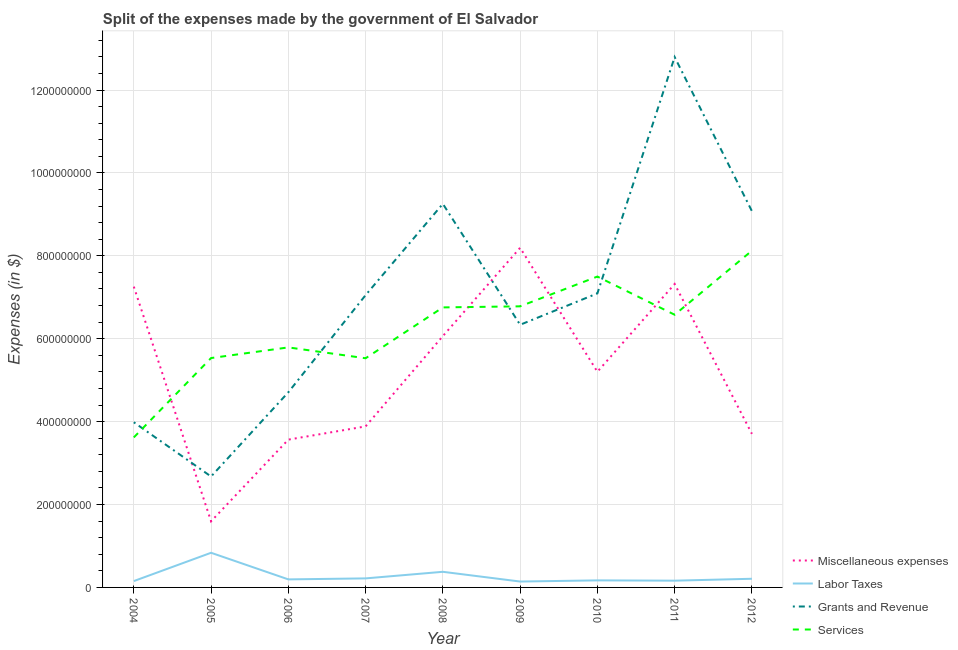Does the line corresponding to amount spent on labor taxes intersect with the line corresponding to amount spent on grants and revenue?
Provide a succinct answer. No. Is the number of lines equal to the number of legend labels?
Your answer should be compact. Yes. What is the amount spent on miscellaneous expenses in 2010?
Offer a very short reply. 5.20e+08. Across all years, what is the maximum amount spent on grants and revenue?
Provide a succinct answer. 1.28e+09. Across all years, what is the minimum amount spent on services?
Keep it short and to the point. 3.62e+08. In which year was the amount spent on grants and revenue minimum?
Offer a very short reply. 2005. What is the total amount spent on labor taxes in the graph?
Ensure brevity in your answer.  2.46e+08. What is the difference between the amount spent on labor taxes in 2011 and that in 2012?
Offer a very short reply. -4.60e+06. What is the difference between the amount spent on grants and revenue in 2004 and the amount spent on labor taxes in 2007?
Offer a very short reply. 3.77e+08. What is the average amount spent on grants and revenue per year?
Your response must be concise. 7.00e+08. In the year 2008, what is the difference between the amount spent on services and amount spent on labor taxes?
Your answer should be compact. 6.38e+08. In how many years, is the amount spent on grants and revenue greater than 80000000 $?
Offer a very short reply. 9. What is the ratio of the amount spent on grants and revenue in 2004 to that in 2008?
Provide a short and direct response. 0.43. Is the amount spent on grants and revenue in 2010 less than that in 2012?
Ensure brevity in your answer.  Yes. Is the difference between the amount spent on services in 2007 and 2008 greater than the difference between the amount spent on miscellaneous expenses in 2007 and 2008?
Your answer should be compact. Yes. What is the difference between the highest and the second highest amount spent on labor taxes?
Your answer should be very brief. 4.59e+07. What is the difference between the highest and the lowest amount spent on services?
Your answer should be very brief. 4.51e+08. Is the sum of the amount spent on labor taxes in 2009 and 2012 greater than the maximum amount spent on services across all years?
Your answer should be very brief. No. Is it the case that in every year, the sum of the amount spent on services and amount spent on labor taxes is greater than the sum of amount spent on miscellaneous expenses and amount spent on grants and revenue?
Make the answer very short. No. Is it the case that in every year, the sum of the amount spent on miscellaneous expenses and amount spent on labor taxes is greater than the amount spent on grants and revenue?
Your answer should be compact. No. Is the amount spent on services strictly less than the amount spent on miscellaneous expenses over the years?
Offer a terse response. No. Does the graph contain any zero values?
Your answer should be very brief. No. Does the graph contain grids?
Your answer should be compact. Yes. What is the title of the graph?
Your response must be concise. Split of the expenses made by the government of El Salvador. Does "Interest Payments" appear as one of the legend labels in the graph?
Provide a short and direct response. No. What is the label or title of the X-axis?
Keep it short and to the point. Year. What is the label or title of the Y-axis?
Give a very brief answer. Expenses (in $). What is the Expenses (in $) of Miscellaneous expenses in 2004?
Ensure brevity in your answer.  7.26e+08. What is the Expenses (in $) in Labor Taxes in 2004?
Your response must be concise. 1.53e+07. What is the Expenses (in $) in Grants and Revenue in 2004?
Offer a very short reply. 3.98e+08. What is the Expenses (in $) of Services in 2004?
Provide a succinct answer. 3.62e+08. What is the Expenses (in $) of Miscellaneous expenses in 2005?
Your response must be concise. 1.60e+08. What is the Expenses (in $) in Labor Taxes in 2005?
Offer a very short reply. 8.36e+07. What is the Expenses (in $) in Grants and Revenue in 2005?
Make the answer very short. 2.68e+08. What is the Expenses (in $) in Services in 2005?
Give a very brief answer. 5.53e+08. What is the Expenses (in $) of Miscellaneous expenses in 2006?
Offer a terse response. 3.57e+08. What is the Expenses (in $) in Labor Taxes in 2006?
Make the answer very short. 1.94e+07. What is the Expenses (in $) of Grants and Revenue in 2006?
Make the answer very short. 4.71e+08. What is the Expenses (in $) of Services in 2006?
Offer a terse response. 5.79e+08. What is the Expenses (in $) of Miscellaneous expenses in 2007?
Provide a succinct answer. 3.88e+08. What is the Expenses (in $) in Labor Taxes in 2007?
Your answer should be compact. 2.18e+07. What is the Expenses (in $) in Grants and Revenue in 2007?
Offer a very short reply. 7.05e+08. What is the Expenses (in $) in Services in 2007?
Your response must be concise. 5.53e+08. What is the Expenses (in $) of Miscellaneous expenses in 2008?
Keep it short and to the point. 6.06e+08. What is the Expenses (in $) of Labor Taxes in 2008?
Provide a short and direct response. 3.77e+07. What is the Expenses (in $) in Grants and Revenue in 2008?
Offer a very short reply. 9.26e+08. What is the Expenses (in $) of Services in 2008?
Provide a short and direct response. 6.76e+08. What is the Expenses (in $) in Miscellaneous expenses in 2009?
Your answer should be compact. 8.19e+08. What is the Expenses (in $) of Labor Taxes in 2009?
Your response must be concise. 1.42e+07. What is the Expenses (in $) in Grants and Revenue in 2009?
Provide a short and direct response. 6.34e+08. What is the Expenses (in $) of Services in 2009?
Your response must be concise. 6.78e+08. What is the Expenses (in $) of Miscellaneous expenses in 2010?
Offer a terse response. 5.20e+08. What is the Expenses (in $) of Labor Taxes in 2010?
Ensure brevity in your answer.  1.70e+07. What is the Expenses (in $) in Grants and Revenue in 2010?
Provide a short and direct response. 7.09e+08. What is the Expenses (in $) in Services in 2010?
Your answer should be very brief. 7.50e+08. What is the Expenses (in $) in Miscellaneous expenses in 2011?
Provide a succinct answer. 7.32e+08. What is the Expenses (in $) in Labor Taxes in 2011?
Your response must be concise. 1.63e+07. What is the Expenses (in $) of Grants and Revenue in 2011?
Keep it short and to the point. 1.28e+09. What is the Expenses (in $) in Services in 2011?
Your answer should be very brief. 6.58e+08. What is the Expenses (in $) of Miscellaneous expenses in 2012?
Your answer should be compact. 3.70e+08. What is the Expenses (in $) in Labor Taxes in 2012?
Offer a very short reply. 2.09e+07. What is the Expenses (in $) of Grants and Revenue in 2012?
Your answer should be very brief. 9.08e+08. What is the Expenses (in $) of Services in 2012?
Offer a terse response. 8.12e+08. Across all years, what is the maximum Expenses (in $) in Miscellaneous expenses?
Provide a short and direct response. 8.19e+08. Across all years, what is the maximum Expenses (in $) in Labor Taxes?
Provide a succinct answer. 8.36e+07. Across all years, what is the maximum Expenses (in $) in Grants and Revenue?
Keep it short and to the point. 1.28e+09. Across all years, what is the maximum Expenses (in $) in Services?
Your response must be concise. 8.12e+08. Across all years, what is the minimum Expenses (in $) in Miscellaneous expenses?
Provide a succinct answer. 1.60e+08. Across all years, what is the minimum Expenses (in $) of Labor Taxes?
Offer a very short reply. 1.42e+07. Across all years, what is the minimum Expenses (in $) in Grants and Revenue?
Give a very brief answer. 2.68e+08. Across all years, what is the minimum Expenses (in $) in Services?
Offer a very short reply. 3.62e+08. What is the total Expenses (in $) in Miscellaneous expenses in the graph?
Provide a succinct answer. 4.68e+09. What is the total Expenses (in $) in Labor Taxes in the graph?
Provide a short and direct response. 2.46e+08. What is the total Expenses (in $) in Grants and Revenue in the graph?
Provide a short and direct response. 6.30e+09. What is the total Expenses (in $) in Services in the graph?
Provide a short and direct response. 5.62e+09. What is the difference between the Expenses (in $) in Miscellaneous expenses in 2004 and that in 2005?
Provide a short and direct response. 5.66e+08. What is the difference between the Expenses (in $) of Labor Taxes in 2004 and that in 2005?
Your response must be concise. -6.83e+07. What is the difference between the Expenses (in $) in Grants and Revenue in 2004 and that in 2005?
Provide a short and direct response. 1.31e+08. What is the difference between the Expenses (in $) of Services in 2004 and that in 2005?
Give a very brief answer. -1.92e+08. What is the difference between the Expenses (in $) in Miscellaneous expenses in 2004 and that in 2006?
Ensure brevity in your answer.  3.69e+08. What is the difference between the Expenses (in $) of Labor Taxes in 2004 and that in 2006?
Provide a short and direct response. -4.10e+06. What is the difference between the Expenses (in $) in Grants and Revenue in 2004 and that in 2006?
Your answer should be very brief. -7.23e+07. What is the difference between the Expenses (in $) in Services in 2004 and that in 2006?
Your answer should be compact. -2.17e+08. What is the difference between the Expenses (in $) in Miscellaneous expenses in 2004 and that in 2007?
Offer a terse response. 3.37e+08. What is the difference between the Expenses (in $) in Labor Taxes in 2004 and that in 2007?
Your response must be concise. -6.50e+06. What is the difference between the Expenses (in $) in Grants and Revenue in 2004 and that in 2007?
Keep it short and to the point. -3.07e+08. What is the difference between the Expenses (in $) in Services in 2004 and that in 2007?
Provide a short and direct response. -1.91e+08. What is the difference between the Expenses (in $) of Miscellaneous expenses in 2004 and that in 2008?
Your answer should be very brief. 1.19e+08. What is the difference between the Expenses (in $) in Labor Taxes in 2004 and that in 2008?
Your answer should be very brief. -2.24e+07. What is the difference between the Expenses (in $) in Grants and Revenue in 2004 and that in 2008?
Provide a succinct answer. -5.27e+08. What is the difference between the Expenses (in $) of Services in 2004 and that in 2008?
Your response must be concise. -3.14e+08. What is the difference between the Expenses (in $) in Miscellaneous expenses in 2004 and that in 2009?
Provide a short and direct response. -9.37e+07. What is the difference between the Expenses (in $) of Labor Taxes in 2004 and that in 2009?
Give a very brief answer. 1.10e+06. What is the difference between the Expenses (in $) in Grants and Revenue in 2004 and that in 2009?
Make the answer very short. -2.35e+08. What is the difference between the Expenses (in $) in Services in 2004 and that in 2009?
Make the answer very short. -3.16e+08. What is the difference between the Expenses (in $) of Miscellaneous expenses in 2004 and that in 2010?
Offer a very short reply. 2.05e+08. What is the difference between the Expenses (in $) of Labor Taxes in 2004 and that in 2010?
Keep it short and to the point. -1.70e+06. What is the difference between the Expenses (in $) of Grants and Revenue in 2004 and that in 2010?
Give a very brief answer. -3.11e+08. What is the difference between the Expenses (in $) in Services in 2004 and that in 2010?
Keep it short and to the point. -3.88e+08. What is the difference between the Expenses (in $) of Miscellaneous expenses in 2004 and that in 2011?
Ensure brevity in your answer.  -6.39e+06. What is the difference between the Expenses (in $) of Grants and Revenue in 2004 and that in 2011?
Provide a succinct answer. -8.81e+08. What is the difference between the Expenses (in $) in Services in 2004 and that in 2011?
Your response must be concise. -2.96e+08. What is the difference between the Expenses (in $) in Miscellaneous expenses in 2004 and that in 2012?
Make the answer very short. 3.55e+08. What is the difference between the Expenses (in $) in Labor Taxes in 2004 and that in 2012?
Make the answer very short. -5.60e+06. What is the difference between the Expenses (in $) in Grants and Revenue in 2004 and that in 2012?
Give a very brief answer. -5.09e+08. What is the difference between the Expenses (in $) in Services in 2004 and that in 2012?
Ensure brevity in your answer.  -4.51e+08. What is the difference between the Expenses (in $) in Miscellaneous expenses in 2005 and that in 2006?
Give a very brief answer. -1.97e+08. What is the difference between the Expenses (in $) in Labor Taxes in 2005 and that in 2006?
Make the answer very short. 6.42e+07. What is the difference between the Expenses (in $) in Grants and Revenue in 2005 and that in 2006?
Provide a succinct answer. -2.03e+08. What is the difference between the Expenses (in $) in Services in 2005 and that in 2006?
Provide a succinct answer. -2.57e+07. What is the difference between the Expenses (in $) in Miscellaneous expenses in 2005 and that in 2007?
Keep it short and to the point. -2.29e+08. What is the difference between the Expenses (in $) of Labor Taxes in 2005 and that in 2007?
Your answer should be compact. 6.18e+07. What is the difference between the Expenses (in $) of Grants and Revenue in 2005 and that in 2007?
Your response must be concise. -4.38e+08. What is the difference between the Expenses (in $) in Services in 2005 and that in 2007?
Your answer should be compact. 5.00e+05. What is the difference between the Expenses (in $) of Miscellaneous expenses in 2005 and that in 2008?
Offer a very short reply. -4.47e+08. What is the difference between the Expenses (in $) of Labor Taxes in 2005 and that in 2008?
Your response must be concise. 4.59e+07. What is the difference between the Expenses (in $) in Grants and Revenue in 2005 and that in 2008?
Make the answer very short. -6.58e+08. What is the difference between the Expenses (in $) in Services in 2005 and that in 2008?
Ensure brevity in your answer.  -1.22e+08. What is the difference between the Expenses (in $) of Miscellaneous expenses in 2005 and that in 2009?
Your answer should be very brief. -6.60e+08. What is the difference between the Expenses (in $) in Labor Taxes in 2005 and that in 2009?
Your response must be concise. 6.94e+07. What is the difference between the Expenses (in $) of Grants and Revenue in 2005 and that in 2009?
Offer a very short reply. -3.66e+08. What is the difference between the Expenses (in $) of Services in 2005 and that in 2009?
Provide a succinct answer. -1.25e+08. What is the difference between the Expenses (in $) of Miscellaneous expenses in 2005 and that in 2010?
Make the answer very short. -3.61e+08. What is the difference between the Expenses (in $) in Labor Taxes in 2005 and that in 2010?
Give a very brief answer. 6.66e+07. What is the difference between the Expenses (in $) of Grants and Revenue in 2005 and that in 2010?
Provide a succinct answer. -4.42e+08. What is the difference between the Expenses (in $) of Services in 2005 and that in 2010?
Provide a succinct answer. -1.97e+08. What is the difference between the Expenses (in $) of Miscellaneous expenses in 2005 and that in 2011?
Give a very brief answer. -5.73e+08. What is the difference between the Expenses (in $) of Labor Taxes in 2005 and that in 2011?
Keep it short and to the point. 6.73e+07. What is the difference between the Expenses (in $) in Grants and Revenue in 2005 and that in 2011?
Ensure brevity in your answer.  -1.01e+09. What is the difference between the Expenses (in $) of Services in 2005 and that in 2011?
Give a very brief answer. -1.04e+08. What is the difference between the Expenses (in $) in Miscellaneous expenses in 2005 and that in 2012?
Your response must be concise. -2.11e+08. What is the difference between the Expenses (in $) of Labor Taxes in 2005 and that in 2012?
Provide a succinct answer. 6.27e+07. What is the difference between the Expenses (in $) in Grants and Revenue in 2005 and that in 2012?
Give a very brief answer. -6.40e+08. What is the difference between the Expenses (in $) in Services in 2005 and that in 2012?
Ensure brevity in your answer.  -2.59e+08. What is the difference between the Expenses (in $) of Miscellaneous expenses in 2006 and that in 2007?
Offer a terse response. -3.19e+07. What is the difference between the Expenses (in $) in Labor Taxes in 2006 and that in 2007?
Your answer should be compact. -2.40e+06. What is the difference between the Expenses (in $) of Grants and Revenue in 2006 and that in 2007?
Your answer should be very brief. -2.34e+08. What is the difference between the Expenses (in $) in Services in 2006 and that in 2007?
Give a very brief answer. 2.62e+07. What is the difference between the Expenses (in $) of Miscellaneous expenses in 2006 and that in 2008?
Give a very brief answer. -2.50e+08. What is the difference between the Expenses (in $) of Labor Taxes in 2006 and that in 2008?
Your response must be concise. -1.83e+07. What is the difference between the Expenses (in $) of Grants and Revenue in 2006 and that in 2008?
Offer a very short reply. -4.55e+08. What is the difference between the Expenses (in $) of Services in 2006 and that in 2008?
Offer a terse response. -9.65e+07. What is the difference between the Expenses (in $) of Miscellaneous expenses in 2006 and that in 2009?
Your response must be concise. -4.63e+08. What is the difference between the Expenses (in $) of Labor Taxes in 2006 and that in 2009?
Keep it short and to the point. 5.20e+06. What is the difference between the Expenses (in $) of Grants and Revenue in 2006 and that in 2009?
Give a very brief answer. -1.63e+08. What is the difference between the Expenses (in $) of Services in 2006 and that in 2009?
Make the answer very short. -9.91e+07. What is the difference between the Expenses (in $) of Miscellaneous expenses in 2006 and that in 2010?
Offer a very short reply. -1.64e+08. What is the difference between the Expenses (in $) of Labor Taxes in 2006 and that in 2010?
Keep it short and to the point. 2.40e+06. What is the difference between the Expenses (in $) of Grants and Revenue in 2006 and that in 2010?
Keep it short and to the point. -2.39e+08. What is the difference between the Expenses (in $) of Services in 2006 and that in 2010?
Offer a very short reply. -1.71e+08. What is the difference between the Expenses (in $) of Miscellaneous expenses in 2006 and that in 2011?
Offer a very short reply. -3.75e+08. What is the difference between the Expenses (in $) of Labor Taxes in 2006 and that in 2011?
Provide a succinct answer. 3.10e+06. What is the difference between the Expenses (in $) of Grants and Revenue in 2006 and that in 2011?
Offer a terse response. -8.09e+08. What is the difference between the Expenses (in $) of Services in 2006 and that in 2011?
Ensure brevity in your answer.  -7.88e+07. What is the difference between the Expenses (in $) in Miscellaneous expenses in 2006 and that in 2012?
Keep it short and to the point. -1.39e+07. What is the difference between the Expenses (in $) of Labor Taxes in 2006 and that in 2012?
Your answer should be very brief. -1.50e+06. What is the difference between the Expenses (in $) in Grants and Revenue in 2006 and that in 2012?
Your response must be concise. -4.37e+08. What is the difference between the Expenses (in $) in Services in 2006 and that in 2012?
Make the answer very short. -2.33e+08. What is the difference between the Expenses (in $) of Miscellaneous expenses in 2007 and that in 2008?
Give a very brief answer. -2.18e+08. What is the difference between the Expenses (in $) in Labor Taxes in 2007 and that in 2008?
Give a very brief answer. -1.59e+07. What is the difference between the Expenses (in $) in Grants and Revenue in 2007 and that in 2008?
Provide a short and direct response. -2.20e+08. What is the difference between the Expenses (in $) of Services in 2007 and that in 2008?
Provide a short and direct response. -1.23e+08. What is the difference between the Expenses (in $) of Miscellaneous expenses in 2007 and that in 2009?
Give a very brief answer. -4.31e+08. What is the difference between the Expenses (in $) of Labor Taxes in 2007 and that in 2009?
Make the answer very short. 7.60e+06. What is the difference between the Expenses (in $) in Grants and Revenue in 2007 and that in 2009?
Provide a succinct answer. 7.15e+07. What is the difference between the Expenses (in $) in Services in 2007 and that in 2009?
Keep it short and to the point. -1.25e+08. What is the difference between the Expenses (in $) of Miscellaneous expenses in 2007 and that in 2010?
Make the answer very short. -1.32e+08. What is the difference between the Expenses (in $) of Labor Taxes in 2007 and that in 2010?
Your response must be concise. 4.80e+06. What is the difference between the Expenses (in $) of Grants and Revenue in 2007 and that in 2010?
Provide a succinct answer. -4.20e+06. What is the difference between the Expenses (in $) of Services in 2007 and that in 2010?
Make the answer very short. -1.97e+08. What is the difference between the Expenses (in $) in Miscellaneous expenses in 2007 and that in 2011?
Your response must be concise. -3.44e+08. What is the difference between the Expenses (in $) in Labor Taxes in 2007 and that in 2011?
Give a very brief answer. 5.50e+06. What is the difference between the Expenses (in $) of Grants and Revenue in 2007 and that in 2011?
Ensure brevity in your answer.  -5.74e+08. What is the difference between the Expenses (in $) in Services in 2007 and that in 2011?
Offer a very short reply. -1.05e+08. What is the difference between the Expenses (in $) of Miscellaneous expenses in 2007 and that in 2012?
Give a very brief answer. 1.80e+07. What is the difference between the Expenses (in $) of Labor Taxes in 2007 and that in 2012?
Offer a very short reply. 9.00e+05. What is the difference between the Expenses (in $) in Grants and Revenue in 2007 and that in 2012?
Provide a succinct answer. -2.03e+08. What is the difference between the Expenses (in $) in Services in 2007 and that in 2012?
Ensure brevity in your answer.  -2.60e+08. What is the difference between the Expenses (in $) of Miscellaneous expenses in 2008 and that in 2009?
Give a very brief answer. -2.13e+08. What is the difference between the Expenses (in $) in Labor Taxes in 2008 and that in 2009?
Ensure brevity in your answer.  2.35e+07. What is the difference between the Expenses (in $) of Grants and Revenue in 2008 and that in 2009?
Offer a terse response. 2.92e+08. What is the difference between the Expenses (in $) of Services in 2008 and that in 2009?
Ensure brevity in your answer.  -2.60e+06. What is the difference between the Expenses (in $) in Miscellaneous expenses in 2008 and that in 2010?
Provide a succinct answer. 8.60e+07. What is the difference between the Expenses (in $) of Labor Taxes in 2008 and that in 2010?
Offer a terse response. 2.07e+07. What is the difference between the Expenses (in $) of Grants and Revenue in 2008 and that in 2010?
Your answer should be compact. 2.16e+08. What is the difference between the Expenses (in $) of Services in 2008 and that in 2010?
Give a very brief answer. -7.44e+07. What is the difference between the Expenses (in $) of Miscellaneous expenses in 2008 and that in 2011?
Make the answer very short. -1.26e+08. What is the difference between the Expenses (in $) of Labor Taxes in 2008 and that in 2011?
Give a very brief answer. 2.14e+07. What is the difference between the Expenses (in $) in Grants and Revenue in 2008 and that in 2011?
Provide a short and direct response. -3.54e+08. What is the difference between the Expenses (in $) in Services in 2008 and that in 2011?
Provide a short and direct response. 1.77e+07. What is the difference between the Expenses (in $) in Miscellaneous expenses in 2008 and that in 2012?
Provide a succinct answer. 2.36e+08. What is the difference between the Expenses (in $) of Labor Taxes in 2008 and that in 2012?
Provide a succinct answer. 1.68e+07. What is the difference between the Expenses (in $) of Grants and Revenue in 2008 and that in 2012?
Make the answer very short. 1.77e+07. What is the difference between the Expenses (in $) in Services in 2008 and that in 2012?
Provide a succinct answer. -1.37e+08. What is the difference between the Expenses (in $) of Miscellaneous expenses in 2009 and that in 2010?
Provide a short and direct response. 2.99e+08. What is the difference between the Expenses (in $) in Labor Taxes in 2009 and that in 2010?
Your answer should be very brief. -2.80e+06. What is the difference between the Expenses (in $) in Grants and Revenue in 2009 and that in 2010?
Provide a succinct answer. -7.57e+07. What is the difference between the Expenses (in $) in Services in 2009 and that in 2010?
Keep it short and to the point. -7.18e+07. What is the difference between the Expenses (in $) of Miscellaneous expenses in 2009 and that in 2011?
Offer a terse response. 8.73e+07. What is the difference between the Expenses (in $) in Labor Taxes in 2009 and that in 2011?
Provide a short and direct response. -2.10e+06. What is the difference between the Expenses (in $) in Grants and Revenue in 2009 and that in 2011?
Your answer should be compact. -6.46e+08. What is the difference between the Expenses (in $) in Services in 2009 and that in 2011?
Ensure brevity in your answer.  2.03e+07. What is the difference between the Expenses (in $) in Miscellaneous expenses in 2009 and that in 2012?
Your answer should be compact. 4.49e+08. What is the difference between the Expenses (in $) in Labor Taxes in 2009 and that in 2012?
Offer a very short reply. -6.70e+06. What is the difference between the Expenses (in $) of Grants and Revenue in 2009 and that in 2012?
Provide a short and direct response. -2.74e+08. What is the difference between the Expenses (in $) of Services in 2009 and that in 2012?
Your answer should be compact. -1.34e+08. What is the difference between the Expenses (in $) of Miscellaneous expenses in 2010 and that in 2011?
Make the answer very short. -2.12e+08. What is the difference between the Expenses (in $) in Labor Taxes in 2010 and that in 2011?
Ensure brevity in your answer.  7.00e+05. What is the difference between the Expenses (in $) in Grants and Revenue in 2010 and that in 2011?
Ensure brevity in your answer.  -5.70e+08. What is the difference between the Expenses (in $) in Services in 2010 and that in 2011?
Ensure brevity in your answer.  9.21e+07. What is the difference between the Expenses (in $) in Miscellaneous expenses in 2010 and that in 2012?
Your answer should be very brief. 1.50e+08. What is the difference between the Expenses (in $) in Labor Taxes in 2010 and that in 2012?
Your answer should be very brief. -3.90e+06. What is the difference between the Expenses (in $) of Grants and Revenue in 2010 and that in 2012?
Offer a very short reply. -1.98e+08. What is the difference between the Expenses (in $) in Services in 2010 and that in 2012?
Give a very brief answer. -6.24e+07. What is the difference between the Expenses (in $) of Miscellaneous expenses in 2011 and that in 2012?
Offer a very short reply. 3.62e+08. What is the difference between the Expenses (in $) in Labor Taxes in 2011 and that in 2012?
Your answer should be compact. -4.60e+06. What is the difference between the Expenses (in $) of Grants and Revenue in 2011 and that in 2012?
Make the answer very short. 3.72e+08. What is the difference between the Expenses (in $) in Services in 2011 and that in 2012?
Keep it short and to the point. -1.55e+08. What is the difference between the Expenses (in $) in Miscellaneous expenses in 2004 and the Expenses (in $) in Labor Taxes in 2005?
Provide a short and direct response. 6.42e+08. What is the difference between the Expenses (in $) of Miscellaneous expenses in 2004 and the Expenses (in $) of Grants and Revenue in 2005?
Your answer should be very brief. 4.58e+08. What is the difference between the Expenses (in $) in Miscellaneous expenses in 2004 and the Expenses (in $) in Services in 2005?
Make the answer very short. 1.72e+08. What is the difference between the Expenses (in $) in Labor Taxes in 2004 and the Expenses (in $) in Grants and Revenue in 2005?
Keep it short and to the point. -2.52e+08. What is the difference between the Expenses (in $) in Labor Taxes in 2004 and the Expenses (in $) in Services in 2005?
Give a very brief answer. -5.38e+08. What is the difference between the Expenses (in $) of Grants and Revenue in 2004 and the Expenses (in $) of Services in 2005?
Keep it short and to the point. -1.55e+08. What is the difference between the Expenses (in $) in Miscellaneous expenses in 2004 and the Expenses (in $) in Labor Taxes in 2006?
Your answer should be very brief. 7.06e+08. What is the difference between the Expenses (in $) of Miscellaneous expenses in 2004 and the Expenses (in $) of Grants and Revenue in 2006?
Offer a very short reply. 2.55e+08. What is the difference between the Expenses (in $) of Miscellaneous expenses in 2004 and the Expenses (in $) of Services in 2006?
Your answer should be very brief. 1.47e+08. What is the difference between the Expenses (in $) in Labor Taxes in 2004 and the Expenses (in $) in Grants and Revenue in 2006?
Provide a succinct answer. -4.56e+08. What is the difference between the Expenses (in $) of Labor Taxes in 2004 and the Expenses (in $) of Services in 2006?
Your answer should be compact. -5.64e+08. What is the difference between the Expenses (in $) of Grants and Revenue in 2004 and the Expenses (in $) of Services in 2006?
Offer a terse response. -1.81e+08. What is the difference between the Expenses (in $) of Miscellaneous expenses in 2004 and the Expenses (in $) of Labor Taxes in 2007?
Offer a very short reply. 7.04e+08. What is the difference between the Expenses (in $) in Miscellaneous expenses in 2004 and the Expenses (in $) in Grants and Revenue in 2007?
Keep it short and to the point. 2.05e+07. What is the difference between the Expenses (in $) in Miscellaneous expenses in 2004 and the Expenses (in $) in Services in 2007?
Give a very brief answer. 1.73e+08. What is the difference between the Expenses (in $) of Labor Taxes in 2004 and the Expenses (in $) of Grants and Revenue in 2007?
Offer a very short reply. -6.90e+08. What is the difference between the Expenses (in $) in Labor Taxes in 2004 and the Expenses (in $) in Services in 2007?
Your answer should be compact. -5.38e+08. What is the difference between the Expenses (in $) in Grants and Revenue in 2004 and the Expenses (in $) in Services in 2007?
Your answer should be compact. -1.54e+08. What is the difference between the Expenses (in $) in Miscellaneous expenses in 2004 and the Expenses (in $) in Labor Taxes in 2008?
Your answer should be compact. 6.88e+08. What is the difference between the Expenses (in $) in Miscellaneous expenses in 2004 and the Expenses (in $) in Grants and Revenue in 2008?
Offer a terse response. -2.00e+08. What is the difference between the Expenses (in $) in Miscellaneous expenses in 2004 and the Expenses (in $) in Services in 2008?
Your answer should be very brief. 5.01e+07. What is the difference between the Expenses (in $) of Labor Taxes in 2004 and the Expenses (in $) of Grants and Revenue in 2008?
Ensure brevity in your answer.  -9.10e+08. What is the difference between the Expenses (in $) of Labor Taxes in 2004 and the Expenses (in $) of Services in 2008?
Your answer should be compact. -6.60e+08. What is the difference between the Expenses (in $) of Grants and Revenue in 2004 and the Expenses (in $) of Services in 2008?
Your answer should be very brief. -2.77e+08. What is the difference between the Expenses (in $) of Miscellaneous expenses in 2004 and the Expenses (in $) of Labor Taxes in 2009?
Offer a terse response. 7.12e+08. What is the difference between the Expenses (in $) of Miscellaneous expenses in 2004 and the Expenses (in $) of Grants and Revenue in 2009?
Your response must be concise. 9.20e+07. What is the difference between the Expenses (in $) in Miscellaneous expenses in 2004 and the Expenses (in $) in Services in 2009?
Offer a very short reply. 4.75e+07. What is the difference between the Expenses (in $) in Labor Taxes in 2004 and the Expenses (in $) in Grants and Revenue in 2009?
Offer a very short reply. -6.18e+08. What is the difference between the Expenses (in $) in Labor Taxes in 2004 and the Expenses (in $) in Services in 2009?
Provide a succinct answer. -6.63e+08. What is the difference between the Expenses (in $) in Grants and Revenue in 2004 and the Expenses (in $) in Services in 2009?
Your answer should be very brief. -2.80e+08. What is the difference between the Expenses (in $) in Miscellaneous expenses in 2004 and the Expenses (in $) in Labor Taxes in 2010?
Offer a very short reply. 7.09e+08. What is the difference between the Expenses (in $) of Miscellaneous expenses in 2004 and the Expenses (in $) of Grants and Revenue in 2010?
Offer a very short reply. 1.63e+07. What is the difference between the Expenses (in $) in Miscellaneous expenses in 2004 and the Expenses (in $) in Services in 2010?
Give a very brief answer. -2.43e+07. What is the difference between the Expenses (in $) of Labor Taxes in 2004 and the Expenses (in $) of Grants and Revenue in 2010?
Your answer should be compact. -6.94e+08. What is the difference between the Expenses (in $) of Labor Taxes in 2004 and the Expenses (in $) of Services in 2010?
Ensure brevity in your answer.  -7.35e+08. What is the difference between the Expenses (in $) of Grants and Revenue in 2004 and the Expenses (in $) of Services in 2010?
Keep it short and to the point. -3.52e+08. What is the difference between the Expenses (in $) in Miscellaneous expenses in 2004 and the Expenses (in $) in Labor Taxes in 2011?
Offer a very short reply. 7.09e+08. What is the difference between the Expenses (in $) of Miscellaneous expenses in 2004 and the Expenses (in $) of Grants and Revenue in 2011?
Offer a very short reply. -5.54e+08. What is the difference between the Expenses (in $) of Miscellaneous expenses in 2004 and the Expenses (in $) of Services in 2011?
Give a very brief answer. 6.78e+07. What is the difference between the Expenses (in $) of Labor Taxes in 2004 and the Expenses (in $) of Grants and Revenue in 2011?
Keep it short and to the point. -1.26e+09. What is the difference between the Expenses (in $) of Labor Taxes in 2004 and the Expenses (in $) of Services in 2011?
Offer a terse response. -6.43e+08. What is the difference between the Expenses (in $) of Grants and Revenue in 2004 and the Expenses (in $) of Services in 2011?
Your answer should be very brief. -2.59e+08. What is the difference between the Expenses (in $) in Miscellaneous expenses in 2004 and the Expenses (in $) in Labor Taxes in 2012?
Give a very brief answer. 7.05e+08. What is the difference between the Expenses (in $) of Miscellaneous expenses in 2004 and the Expenses (in $) of Grants and Revenue in 2012?
Your answer should be compact. -1.82e+08. What is the difference between the Expenses (in $) in Miscellaneous expenses in 2004 and the Expenses (in $) in Services in 2012?
Provide a short and direct response. -8.67e+07. What is the difference between the Expenses (in $) of Labor Taxes in 2004 and the Expenses (in $) of Grants and Revenue in 2012?
Your response must be concise. -8.93e+08. What is the difference between the Expenses (in $) in Labor Taxes in 2004 and the Expenses (in $) in Services in 2012?
Make the answer very short. -7.97e+08. What is the difference between the Expenses (in $) of Grants and Revenue in 2004 and the Expenses (in $) of Services in 2012?
Provide a succinct answer. -4.14e+08. What is the difference between the Expenses (in $) in Miscellaneous expenses in 2005 and the Expenses (in $) in Labor Taxes in 2006?
Provide a short and direct response. 1.40e+08. What is the difference between the Expenses (in $) of Miscellaneous expenses in 2005 and the Expenses (in $) of Grants and Revenue in 2006?
Make the answer very short. -3.11e+08. What is the difference between the Expenses (in $) of Miscellaneous expenses in 2005 and the Expenses (in $) of Services in 2006?
Your response must be concise. -4.20e+08. What is the difference between the Expenses (in $) in Labor Taxes in 2005 and the Expenses (in $) in Grants and Revenue in 2006?
Make the answer very short. -3.87e+08. What is the difference between the Expenses (in $) in Labor Taxes in 2005 and the Expenses (in $) in Services in 2006?
Make the answer very short. -4.96e+08. What is the difference between the Expenses (in $) in Grants and Revenue in 2005 and the Expenses (in $) in Services in 2006?
Offer a terse response. -3.12e+08. What is the difference between the Expenses (in $) in Miscellaneous expenses in 2005 and the Expenses (in $) in Labor Taxes in 2007?
Keep it short and to the point. 1.38e+08. What is the difference between the Expenses (in $) of Miscellaneous expenses in 2005 and the Expenses (in $) of Grants and Revenue in 2007?
Keep it short and to the point. -5.46e+08. What is the difference between the Expenses (in $) in Miscellaneous expenses in 2005 and the Expenses (in $) in Services in 2007?
Make the answer very short. -3.93e+08. What is the difference between the Expenses (in $) of Labor Taxes in 2005 and the Expenses (in $) of Grants and Revenue in 2007?
Give a very brief answer. -6.22e+08. What is the difference between the Expenses (in $) of Labor Taxes in 2005 and the Expenses (in $) of Services in 2007?
Your answer should be very brief. -4.69e+08. What is the difference between the Expenses (in $) in Grants and Revenue in 2005 and the Expenses (in $) in Services in 2007?
Offer a very short reply. -2.85e+08. What is the difference between the Expenses (in $) of Miscellaneous expenses in 2005 and the Expenses (in $) of Labor Taxes in 2008?
Provide a short and direct response. 1.22e+08. What is the difference between the Expenses (in $) in Miscellaneous expenses in 2005 and the Expenses (in $) in Grants and Revenue in 2008?
Offer a very short reply. -7.66e+08. What is the difference between the Expenses (in $) in Miscellaneous expenses in 2005 and the Expenses (in $) in Services in 2008?
Your answer should be very brief. -5.16e+08. What is the difference between the Expenses (in $) in Labor Taxes in 2005 and the Expenses (in $) in Grants and Revenue in 2008?
Your answer should be compact. -8.42e+08. What is the difference between the Expenses (in $) of Labor Taxes in 2005 and the Expenses (in $) of Services in 2008?
Your response must be concise. -5.92e+08. What is the difference between the Expenses (in $) in Grants and Revenue in 2005 and the Expenses (in $) in Services in 2008?
Your answer should be very brief. -4.08e+08. What is the difference between the Expenses (in $) in Miscellaneous expenses in 2005 and the Expenses (in $) in Labor Taxes in 2009?
Provide a short and direct response. 1.45e+08. What is the difference between the Expenses (in $) of Miscellaneous expenses in 2005 and the Expenses (in $) of Grants and Revenue in 2009?
Your answer should be very brief. -4.74e+08. What is the difference between the Expenses (in $) in Miscellaneous expenses in 2005 and the Expenses (in $) in Services in 2009?
Offer a very short reply. -5.19e+08. What is the difference between the Expenses (in $) in Labor Taxes in 2005 and the Expenses (in $) in Grants and Revenue in 2009?
Provide a short and direct response. -5.50e+08. What is the difference between the Expenses (in $) in Labor Taxes in 2005 and the Expenses (in $) in Services in 2009?
Keep it short and to the point. -5.95e+08. What is the difference between the Expenses (in $) in Grants and Revenue in 2005 and the Expenses (in $) in Services in 2009?
Provide a succinct answer. -4.11e+08. What is the difference between the Expenses (in $) in Miscellaneous expenses in 2005 and the Expenses (in $) in Labor Taxes in 2010?
Offer a very short reply. 1.42e+08. What is the difference between the Expenses (in $) in Miscellaneous expenses in 2005 and the Expenses (in $) in Grants and Revenue in 2010?
Make the answer very short. -5.50e+08. What is the difference between the Expenses (in $) in Miscellaneous expenses in 2005 and the Expenses (in $) in Services in 2010?
Provide a short and direct response. -5.90e+08. What is the difference between the Expenses (in $) of Labor Taxes in 2005 and the Expenses (in $) of Grants and Revenue in 2010?
Keep it short and to the point. -6.26e+08. What is the difference between the Expenses (in $) of Labor Taxes in 2005 and the Expenses (in $) of Services in 2010?
Provide a succinct answer. -6.66e+08. What is the difference between the Expenses (in $) of Grants and Revenue in 2005 and the Expenses (in $) of Services in 2010?
Offer a very short reply. -4.82e+08. What is the difference between the Expenses (in $) in Miscellaneous expenses in 2005 and the Expenses (in $) in Labor Taxes in 2011?
Keep it short and to the point. 1.43e+08. What is the difference between the Expenses (in $) in Miscellaneous expenses in 2005 and the Expenses (in $) in Grants and Revenue in 2011?
Keep it short and to the point. -1.12e+09. What is the difference between the Expenses (in $) in Miscellaneous expenses in 2005 and the Expenses (in $) in Services in 2011?
Your answer should be compact. -4.98e+08. What is the difference between the Expenses (in $) of Labor Taxes in 2005 and the Expenses (in $) of Grants and Revenue in 2011?
Your response must be concise. -1.20e+09. What is the difference between the Expenses (in $) of Labor Taxes in 2005 and the Expenses (in $) of Services in 2011?
Offer a terse response. -5.74e+08. What is the difference between the Expenses (in $) in Grants and Revenue in 2005 and the Expenses (in $) in Services in 2011?
Provide a short and direct response. -3.90e+08. What is the difference between the Expenses (in $) in Miscellaneous expenses in 2005 and the Expenses (in $) in Labor Taxes in 2012?
Keep it short and to the point. 1.39e+08. What is the difference between the Expenses (in $) of Miscellaneous expenses in 2005 and the Expenses (in $) of Grants and Revenue in 2012?
Make the answer very short. -7.48e+08. What is the difference between the Expenses (in $) of Miscellaneous expenses in 2005 and the Expenses (in $) of Services in 2012?
Offer a terse response. -6.53e+08. What is the difference between the Expenses (in $) in Labor Taxes in 2005 and the Expenses (in $) in Grants and Revenue in 2012?
Offer a very short reply. -8.24e+08. What is the difference between the Expenses (in $) of Labor Taxes in 2005 and the Expenses (in $) of Services in 2012?
Your response must be concise. -7.29e+08. What is the difference between the Expenses (in $) of Grants and Revenue in 2005 and the Expenses (in $) of Services in 2012?
Ensure brevity in your answer.  -5.45e+08. What is the difference between the Expenses (in $) in Miscellaneous expenses in 2006 and the Expenses (in $) in Labor Taxes in 2007?
Your answer should be very brief. 3.35e+08. What is the difference between the Expenses (in $) of Miscellaneous expenses in 2006 and the Expenses (in $) of Grants and Revenue in 2007?
Offer a terse response. -3.49e+08. What is the difference between the Expenses (in $) in Miscellaneous expenses in 2006 and the Expenses (in $) in Services in 2007?
Offer a terse response. -1.96e+08. What is the difference between the Expenses (in $) in Labor Taxes in 2006 and the Expenses (in $) in Grants and Revenue in 2007?
Offer a terse response. -6.86e+08. What is the difference between the Expenses (in $) of Labor Taxes in 2006 and the Expenses (in $) of Services in 2007?
Your answer should be very brief. -5.34e+08. What is the difference between the Expenses (in $) of Grants and Revenue in 2006 and the Expenses (in $) of Services in 2007?
Ensure brevity in your answer.  -8.21e+07. What is the difference between the Expenses (in $) in Miscellaneous expenses in 2006 and the Expenses (in $) in Labor Taxes in 2008?
Make the answer very short. 3.19e+08. What is the difference between the Expenses (in $) of Miscellaneous expenses in 2006 and the Expenses (in $) of Grants and Revenue in 2008?
Provide a succinct answer. -5.69e+08. What is the difference between the Expenses (in $) of Miscellaneous expenses in 2006 and the Expenses (in $) of Services in 2008?
Make the answer very short. -3.19e+08. What is the difference between the Expenses (in $) of Labor Taxes in 2006 and the Expenses (in $) of Grants and Revenue in 2008?
Offer a terse response. -9.06e+08. What is the difference between the Expenses (in $) of Labor Taxes in 2006 and the Expenses (in $) of Services in 2008?
Give a very brief answer. -6.56e+08. What is the difference between the Expenses (in $) of Grants and Revenue in 2006 and the Expenses (in $) of Services in 2008?
Offer a terse response. -2.05e+08. What is the difference between the Expenses (in $) in Miscellaneous expenses in 2006 and the Expenses (in $) in Labor Taxes in 2009?
Keep it short and to the point. 3.42e+08. What is the difference between the Expenses (in $) in Miscellaneous expenses in 2006 and the Expenses (in $) in Grants and Revenue in 2009?
Keep it short and to the point. -2.77e+08. What is the difference between the Expenses (in $) in Miscellaneous expenses in 2006 and the Expenses (in $) in Services in 2009?
Provide a short and direct response. -3.22e+08. What is the difference between the Expenses (in $) in Labor Taxes in 2006 and the Expenses (in $) in Grants and Revenue in 2009?
Keep it short and to the point. -6.14e+08. What is the difference between the Expenses (in $) in Labor Taxes in 2006 and the Expenses (in $) in Services in 2009?
Provide a succinct answer. -6.59e+08. What is the difference between the Expenses (in $) in Grants and Revenue in 2006 and the Expenses (in $) in Services in 2009?
Your answer should be compact. -2.07e+08. What is the difference between the Expenses (in $) in Miscellaneous expenses in 2006 and the Expenses (in $) in Labor Taxes in 2010?
Keep it short and to the point. 3.40e+08. What is the difference between the Expenses (in $) of Miscellaneous expenses in 2006 and the Expenses (in $) of Grants and Revenue in 2010?
Your response must be concise. -3.53e+08. What is the difference between the Expenses (in $) in Miscellaneous expenses in 2006 and the Expenses (in $) in Services in 2010?
Provide a succinct answer. -3.93e+08. What is the difference between the Expenses (in $) in Labor Taxes in 2006 and the Expenses (in $) in Grants and Revenue in 2010?
Offer a terse response. -6.90e+08. What is the difference between the Expenses (in $) of Labor Taxes in 2006 and the Expenses (in $) of Services in 2010?
Your response must be concise. -7.31e+08. What is the difference between the Expenses (in $) of Grants and Revenue in 2006 and the Expenses (in $) of Services in 2010?
Offer a very short reply. -2.79e+08. What is the difference between the Expenses (in $) in Miscellaneous expenses in 2006 and the Expenses (in $) in Labor Taxes in 2011?
Your response must be concise. 3.40e+08. What is the difference between the Expenses (in $) of Miscellaneous expenses in 2006 and the Expenses (in $) of Grants and Revenue in 2011?
Offer a very short reply. -9.23e+08. What is the difference between the Expenses (in $) of Miscellaneous expenses in 2006 and the Expenses (in $) of Services in 2011?
Offer a very short reply. -3.01e+08. What is the difference between the Expenses (in $) of Labor Taxes in 2006 and the Expenses (in $) of Grants and Revenue in 2011?
Offer a very short reply. -1.26e+09. What is the difference between the Expenses (in $) of Labor Taxes in 2006 and the Expenses (in $) of Services in 2011?
Keep it short and to the point. -6.38e+08. What is the difference between the Expenses (in $) of Grants and Revenue in 2006 and the Expenses (in $) of Services in 2011?
Give a very brief answer. -1.87e+08. What is the difference between the Expenses (in $) of Miscellaneous expenses in 2006 and the Expenses (in $) of Labor Taxes in 2012?
Ensure brevity in your answer.  3.36e+08. What is the difference between the Expenses (in $) in Miscellaneous expenses in 2006 and the Expenses (in $) in Grants and Revenue in 2012?
Provide a succinct answer. -5.51e+08. What is the difference between the Expenses (in $) in Miscellaneous expenses in 2006 and the Expenses (in $) in Services in 2012?
Your answer should be compact. -4.56e+08. What is the difference between the Expenses (in $) of Labor Taxes in 2006 and the Expenses (in $) of Grants and Revenue in 2012?
Provide a short and direct response. -8.88e+08. What is the difference between the Expenses (in $) in Labor Taxes in 2006 and the Expenses (in $) in Services in 2012?
Your answer should be very brief. -7.93e+08. What is the difference between the Expenses (in $) in Grants and Revenue in 2006 and the Expenses (in $) in Services in 2012?
Keep it short and to the point. -3.42e+08. What is the difference between the Expenses (in $) in Miscellaneous expenses in 2007 and the Expenses (in $) in Labor Taxes in 2008?
Offer a very short reply. 3.51e+08. What is the difference between the Expenses (in $) in Miscellaneous expenses in 2007 and the Expenses (in $) in Grants and Revenue in 2008?
Give a very brief answer. -5.37e+08. What is the difference between the Expenses (in $) in Miscellaneous expenses in 2007 and the Expenses (in $) in Services in 2008?
Give a very brief answer. -2.87e+08. What is the difference between the Expenses (in $) of Labor Taxes in 2007 and the Expenses (in $) of Grants and Revenue in 2008?
Make the answer very short. -9.04e+08. What is the difference between the Expenses (in $) in Labor Taxes in 2007 and the Expenses (in $) in Services in 2008?
Ensure brevity in your answer.  -6.54e+08. What is the difference between the Expenses (in $) of Grants and Revenue in 2007 and the Expenses (in $) of Services in 2008?
Your answer should be very brief. 2.96e+07. What is the difference between the Expenses (in $) of Miscellaneous expenses in 2007 and the Expenses (in $) of Labor Taxes in 2009?
Keep it short and to the point. 3.74e+08. What is the difference between the Expenses (in $) in Miscellaneous expenses in 2007 and the Expenses (in $) in Grants and Revenue in 2009?
Provide a succinct answer. -2.45e+08. What is the difference between the Expenses (in $) in Miscellaneous expenses in 2007 and the Expenses (in $) in Services in 2009?
Provide a succinct answer. -2.90e+08. What is the difference between the Expenses (in $) of Labor Taxes in 2007 and the Expenses (in $) of Grants and Revenue in 2009?
Offer a very short reply. -6.12e+08. What is the difference between the Expenses (in $) of Labor Taxes in 2007 and the Expenses (in $) of Services in 2009?
Give a very brief answer. -6.56e+08. What is the difference between the Expenses (in $) in Grants and Revenue in 2007 and the Expenses (in $) in Services in 2009?
Make the answer very short. 2.70e+07. What is the difference between the Expenses (in $) of Miscellaneous expenses in 2007 and the Expenses (in $) of Labor Taxes in 2010?
Your answer should be compact. 3.72e+08. What is the difference between the Expenses (in $) in Miscellaneous expenses in 2007 and the Expenses (in $) in Grants and Revenue in 2010?
Give a very brief answer. -3.21e+08. What is the difference between the Expenses (in $) in Miscellaneous expenses in 2007 and the Expenses (in $) in Services in 2010?
Keep it short and to the point. -3.62e+08. What is the difference between the Expenses (in $) of Labor Taxes in 2007 and the Expenses (in $) of Grants and Revenue in 2010?
Provide a short and direct response. -6.88e+08. What is the difference between the Expenses (in $) of Labor Taxes in 2007 and the Expenses (in $) of Services in 2010?
Offer a very short reply. -7.28e+08. What is the difference between the Expenses (in $) in Grants and Revenue in 2007 and the Expenses (in $) in Services in 2010?
Provide a succinct answer. -4.48e+07. What is the difference between the Expenses (in $) in Miscellaneous expenses in 2007 and the Expenses (in $) in Labor Taxes in 2011?
Offer a terse response. 3.72e+08. What is the difference between the Expenses (in $) of Miscellaneous expenses in 2007 and the Expenses (in $) of Grants and Revenue in 2011?
Ensure brevity in your answer.  -8.91e+08. What is the difference between the Expenses (in $) of Miscellaneous expenses in 2007 and the Expenses (in $) of Services in 2011?
Offer a terse response. -2.69e+08. What is the difference between the Expenses (in $) of Labor Taxes in 2007 and the Expenses (in $) of Grants and Revenue in 2011?
Your response must be concise. -1.26e+09. What is the difference between the Expenses (in $) in Labor Taxes in 2007 and the Expenses (in $) in Services in 2011?
Keep it short and to the point. -6.36e+08. What is the difference between the Expenses (in $) in Grants and Revenue in 2007 and the Expenses (in $) in Services in 2011?
Provide a succinct answer. 4.73e+07. What is the difference between the Expenses (in $) in Miscellaneous expenses in 2007 and the Expenses (in $) in Labor Taxes in 2012?
Your answer should be compact. 3.68e+08. What is the difference between the Expenses (in $) in Miscellaneous expenses in 2007 and the Expenses (in $) in Grants and Revenue in 2012?
Make the answer very short. -5.19e+08. What is the difference between the Expenses (in $) in Miscellaneous expenses in 2007 and the Expenses (in $) in Services in 2012?
Keep it short and to the point. -4.24e+08. What is the difference between the Expenses (in $) of Labor Taxes in 2007 and the Expenses (in $) of Grants and Revenue in 2012?
Your response must be concise. -8.86e+08. What is the difference between the Expenses (in $) of Labor Taxes in 2007 and the Expenses (in $) of Services in 2012?
Provide a succinct answer. -7.91e+08. What is the difference between the Expenses (in $) in Grants and Revenue in 2007 and the Expenses (in $) in Services in 2012?
Make the answer very short. -1.07e+08. What is the difference between the Expenses (in $) in Miscellaneous expenses in 2008 and the Expenses (in $) in Labor Taxes in 2009?
Offer a terse response. 5.92e+08. What is the difference between the Expenses (in $) in Miscellaneous expenses in 2008 and the Expenses (in $) in Grants and Revenue in 2009?
Provide a succinct answer. -2.73e+07. What is the difference between the Expenses (in $) in Miscellaneous expenses in 2008 and the Expenses (in $) in Services in 2009?
Provide a succinct answer. -7.18e+07. What is the difference between the Expenses (in $) of Labor Taxes in 2008 and the Expenses (in $) of Grants and Revenue in 2009?
Offer a terse response. -5.96e+08. What is the difference between the Expenses (in $) in Labor Taxes in 2008 and the Expenses (in $) in Services in 2009?
Make the answer very short. -6.40e+08. What is the difference between the Expenses (in $) of Grants and Revenue in 2008 and the Expenses (in $) of Services in 2009?
Give a very brief answer. 2.47e+08. What is the difference between the Expenses (in $) in Miscellaneous expenses in 2008 and the Expenses (in $) in Labor Taxes in 2010?
Ensure brevity in your answer.  5.89e+08. What is the difference between the Expenses (in $) in Miscellaneous expenses in 2008 and the Expenses (in $) in Grants and Revenue in 2010?
Provide a short and direct response. -1.03e+08. What is the difference between the Expenses (in $) of Miscellaneous expenses in 2008 and the Expenses (in $) of Services in 2010?
Your response must be concise. -1.44e+08. What is the difference between the Expenses (in $) of Labor Taxes in 2008 and the Expenses (in $) of Grants and Revenue in 2010?
Your answer should be compact. -6.72e+08. What is the difference between the Expenses (in $) of Labor Taxes in 2008 and the Expenses (in $) of Services in 2010?
Ensure brevity in your answer.  -7.12e+08. What is the difference between the Expenses (in $) in Grants and Revenue in 2008 and the Expenses (in $) in Services in 2010?
Make the answer very short. 1.76e+08. What is the difference between the Expenses (in $) of Miscellaneous expenses in 2008 and the Expenses (in $) of Labor Taxes in 2011?
Keep it short and to the point. 5.90e+08. What is the difference between the Expenses (in $) in Miscellaneous expenses in 2008 and the Expenses (in $) in Grants and Revenue in 2011?
Your response must be concise. -6.73e+08. What is the difference between the Expenses (in $) of Miscellaneous expenses in 2008 and the Expenses (in $) of Services in 2011?
Keep it short and to the point. -5.15e+07. What is the difference between the Expenses (in $) of Labor Taxes in 2008 and the Expenses (in $) of Grants and Revenue in 2011?
Keep it short and to the point. -1.24e+09. What is the difference between the Expenses (in $) of Labor Taxes in 2008 and the Expenses (in $) of Services in 2011?
Offer a terse response. -6.20e+08. What is the difference between the Expenses (in $) of Grants and Revenue in 2008 and the Expenses (in $) of Services in 2011?
Keep it short and to the point. 2.68e+08. What is the difference between the Expenses (in $) of Miscellaneous expenses in 2008 and the Expenses (in $) of Labor Taxes in 2012?
Offer a very short reply. 5.86e+08. What is the difference between the Expenses (in $) in Miscellaneous expenses in 2008 and the Expenses (in $) in Grants and Revenue in 2012?
Provide a short and direct response. -3.01e+08. What is the difference between the Expenses (in $) of Miscellaneous expenses in 2008 and the Expenses (in $) of Services in 2012?
Keep it short and to the point. -2.06e+08. What is the difference between the Expenses (in $) of Labor Taxes in 2008 and the Expenses (in $) of Grants and Revenue in 2012?
Ensure brevity in your answer.  -8.70e+08. What is the difference between the Expenses (in $) in Labor Taxes in 2008 and the Expenses (in $) in Services in 2012?
Provide a succinct answer. -7.75e+08. What is the difference between the Expenses (in $) in Grants and Revenue in 2008 and the Expenses (in $) in Services in 2012?
Provide a short and direct response. 1.13e+08. What is the difference between the Expenses (in $) of Miscellaneous expenses in 2009 and the Expenses (in $) of Labor Taxes in 2010?
Your answer should be compact. 8.02e+08. What is the difference between the Expenses (in $) in Miscellaneous expenses in 2009 and the Expenses (in $) in Grants and Revenue in 2010?
Offer a very short reply. 1.10e+08. What is the difference between the Expenses (in $) in Miscellaneous expenses in 2009 and the Expenses (in $) in Services in 2010?
Provide a succinct answer. 6.94e+07. What is the difference between the Expenses (in $) in Labor Taxes in 2009 and the Expenses (in $) in Grants and Revenue in 2010?
Your answer should be very brief. -6.95e+08. What is the difference between the Expenses (in $) of Labor Taxes in 2009 and the Expenses (in $) of Services in 2010?
Provide a short and direct response. -7.36e+08. What is the difference between the Expenses (in $) of Grants and Revenue in 2009 and the Expenses (in $) of Services in 2010?
Make the answer very short. -1.16e+08. What is the difference between the Expenses (in $) in Miscellaneous expenses in 2009 and the Expenses (in $) in Labor Taxes in 2011?
Your response must be concise. 8.03e+08. What is the difference between the Expenses (in $) in Miscellaneous expenses in 2009 and the Expenses (in $) in Grants and Revenue in 2011?
Offer a terse response. -4.60e+08. What is the difference between the Expenses (in $) in Miscellaneous expenses in 2009 and the Expenses (in $) in Services in 2011?
Your answer should be compact. 1.62e+08. What is the difference between the Expenses (in $) of Labor Taxes in 2009 and the Expenses (in $) of Grants and Revenue in 2011?
Provide a succinct answer. -1.27e+09. What is the difference between the Expenses (in $) in Labor Taxes in 2009 and the Expenses (in $) in Services in 2011?
Keep it short and to the point. -6.44e+08. What is the difference between the Expenses (in $) of Grants and Revenue in 2009 and the Expenses (in $) of Services in 2011?
Make the answer very short. -2.42e+07. What is the difference between the Expenses (in $) of Miscellaneous expenses in 2009 and the Expenses (in $) of Labor Taxes in 2012?
Offer a very short reply. 7.98e+08. What is the difference between the Expenses (in $) in Miscellaneous expenses in 2009 and the Expenses (in $) in Grants and Revenue in 2012?
Offer a very short reply. -8.84e+07. What is the difference between the Expenses (in $) in Miscellaneous expenses in 2009 and the Expenses (in $) in Services in 2012?
Keep it short and to the point. 6.96e+06. What is the difference between the Expenses (in $) of Labor Taxes in 2009 and the Expenses (in $) of Grants and Revenue in 2012?
Keep it short and to the point. -8.94e+08. What is the difference between the Expenses (in $) of Labor Taxes in 2009 and the Expenses (in $) of Services in 2012?
Ensure brevity in your answer.  -7.98e+08. What is the difference between the Expenses (in $) of Grants and Revenue in 2009 and the Expenses (in $) of Services in 2012?
Provide a succinct answer. -1.79e+08. What is the difference between the Expenses (in $) in Miscellaneous expenses in 2010 and the Expenses (in $) in Labor Taxes in 2011?
Provide a succinct answer. 5.04e+08. What is the difference between the Expenses (in $) in Miscellaneous expenses in 2010 and the Expenses (in $) in Grants and Revenue in 2011?
Make the answer very short. -7.59e+08. What is the difference between the Expenses (in $) in Miscellaneous expenses in 2010 and the Expenses (in $) in Services in 2011?
Your answer should be very brief. -1.38e+08. What is the difference between the Expenses (in $) in Labor Taxes in 2010 and the Expenses (in $) in Grants and Revenue in 2011?
Your response must be concise. -1.26e+09. What is the difference between the Expenses (in $) in Labor Taxes in 2010 and the Expenses (in $) in Services in 2011?
Offer a terse response. -6.41e+08. What is the difference between the Expenses (in $) in Grants and Revenue in 2010 and the Expenses (in $) in Services in 2011?
Make the answer very short. 5.15e+07. What is the difference between the Expenses (in $) of Miscellaneous expenses in 2010 and the Expenses (in $) of Labor Taxes in 2012?
Your answer should be compact. 5.00e+08. What is the difference between the Expenses (in $) in Miscellaneous expenses in 2010 and the Expenses (in $) in Grants and Revenue in 2012?
Provide a succinct answer. -3.87e+08. What is the difference between the Expenses (in $) of Miscellaneous expenses in 2010 and the Expenses (in $) of Services in 2012?
Offer a very short reply. -2.92e+08. What is the difference between the Expenses (in $) of Labor Taxes in 2010 and the Expenses (in $) of Grants and Revenue in 2012?
Your answer should be very brief. -8.91e+08. What is the difference between the Expenses (in $) in Labor Taxes in 2010 and the Expenses (in $) in Services in 2012?
Your response must be concise. -7.95e+08. What is the difference between the Expenses (in $) in Grants and Revenue in 2010 and the Expenses (in $) in Services in 2012?
Offer a terse response. -1.03e+08. What is the difference between the Expenses (in $) of Miscellaneous expenses in 2011 and the Expenses (in $) of Labor Taxes in 2012?
Your answer should be very brief. 7.11e+08. What is the difference between the Expenses (in $) of Miscellaneous expenses in 2011 and the Expenses (in $) of Grants and Revenue in 2012?
Offer a very short reply. -1.76e+08. What is the difference between the Expenses (in $) in Miscellaneous expenses in 2011 and the Expenses (in $) in Services in 2012?
Your answer should be compact. -8.03e+07. What is the difference between the Expenses (in $) in Labor Taxes in 2011 and the Expenses (in $) in Grants and Revenue in 2012?
Your answer should be very brief. -8.92e+08. What is the difference between the Expenses (in $) of Labor Taxes in 2011 and the Expenses (in $) of Services in 2012?
Give a very brief answer. -7.96e+08. What is the difference between the Expenses (in $) in Grants and Revenue in 2011 and the Expenses (in $) in Services in 2012?
Give a very brief answer. 4.67e+08. What is the average Expenses (in $) in Miscellaneous expenses per year?
Give a very brief answer. 5.20e+08. What is the average Expenses (in $) of Labor Taxes per year?
Your response must be concise. 2.74e+07. What is the average Expenses (in $) in Grants and Revenue per year?
Make the answer very short. 7.00e+08. What is the average Expenses (in $) of Services per year?
Offer a terse response. 6.25e+08. In the year 2004, what is the difference between the Expenses (in $) in Miscellaneous expenses and Expenses (in $) in Labor Taxes?
Make the answer very short. 7.10e+08. In the year 2004, what is the difference between the Expenses (in $) in Miscellaneous expenses and Expenses (in $) in Grants and Revenue?
Provide a short and direct response. 3.27e+08. In the year 2004, what is the difference between the Expenses (in $) of Miscellaneous expenses and Expenses (in $) of Services?
Your answer should be very brief. 3.64e+08. In the year 2004, what is the difference between the Expenses (in $) in Labor Taxes and Expenses (in $) in Grants and Revenue?
Your answer should be very brief. -3.83e+08. In the year 2004, what is the difference between the Expenses (in $) in Labor Taxes and Expenses (in $) in Services?
Your answer should be very brief. -3.47e+08. In the year 2004, what is the difference between the Expenses (in $) of Grants and Revenue and Expenses (in $) of Services?
Give a very brief answer. 3.66e+07. In the year 2005, what is the difference between the Expenses (in $) in Miscellaneous expenses and Expenses (in $) in Labor Taxes?
Provide a short and direct response. 7.59e+07. In the year 2005, what is the difference between the Expenses (in $) of Miscellaneous expenses and Expenses (in $) of Grants and Revenue?
Offer a very short reply. -1.08e+08. In the year 2005, what is the difference between the Expenses (in $) in Miscellaneous expenses and Expenses (in $) in Services?
Your response must be concise. -3.94e+08. In the year 2005, what is the difference between the Expenses (in $) of Labor Taxes and Expenses (in $) of Grants and Revenue?
Provide a succinct answer. -1.84e+08. In the year 2005, what is the difference between the Expenses (in $) of Labor Taxes and Expenses (in $) of Services?
Give a very brief answer. -4.70e+08. In the year 2005, what is the difference between the Expenses (in $) in Grants and Revenue and Expenses (in $) in Services?
Offer a terse response. -2.86e+08. In the year 2006, what is the difference between the Expenses (in $) in Miscellaneous expenses and Expenses (in $) in Labor Taxes?
Offer a terse response. 3.37e+08. In the year 2006, what is the difference between the Expenses (in $) of Miscellaneous expenses and Expenses (in $) of Grants and Revenue?
Your response must be concise. -1.14e+08. In the year 2006, what is the difference between the Expenses (in $) in Miscellaneous expenses and Expenses (in $) in Services?
Offer a very short reply. -2.22e+08. In the year 2006, what is the difference between the Expenses (in $) of Labor Taxes and Expenses (in $) of Grants and Revenue?
Your answer should be very brief. -4.51e+08. In the year 2006, what is the difference between the Expenses (in $) in Labor Taxes and Expenses (in $) in Services?
Offer a very short reply. -5.60e+08. In the year 2006, what is the difference between the Expenses (in $) of Grants and Revenue and Expenses (in $) of Services?
Offer a terse response. -1.08e+08. In the year 2007, what is the difference between the Expenses (in $) of Miscellaneous expenses and Expenses (in $) of Labor Taxes?
Your answer should be compact. 3.67e+08. In the year 2007, what is the difference between the Expenses (in $) in Miscellaneous expenses and Expenses (in $) in Grants and Revenue?
Provide a short and direct response. -3.17e+08. In the year 2007, what is the difference between the Expenses (in $) in Miscellaneous expenses and Expenses (in $) in Services?
Your answer should be compact. -1.64e+08. In the year 2007, what is the difference between the Expenses (in $) in Labor Taxes and Expenses (in $) in Grants and Revenue?
Provide a succinct answer. -6.83e+08. In the year 2007, what is the difference between the Expenses (in $) in Labor Taxes and Expenses (in $) in Services?
Provide a short and direct response. -5.31e+08. In the year 2007, what is the difference between the Expenses (in $) in Grants and Revenue and Expenses (in $) in Services?
Offer a very short reply. 1.52e+08. In the year 2008, what is the difference between the Expenses (in $) of Miscellaneous expenses and Expenses (in $) of Labor Taxes?
Provide a succinct answer. 5.69e+08. In the year 2008, what is the difference between the Expenses (in $) in Miscellaneous expenses and Expenses (in $) in Grants and Revenue?
Your response must be concise. -3.19e+08. In the year 2008, what is the difference between the Expenses (in $) of Miscellaneous expenses and Expenses (in $) of Services?
Offer a terse response. -6.92e+07. In the year 2008, what is the difference between the Expenses (in $) of Labor Taxes and Expenses (in $) of Grants and Revenue?
Your answer should be compact. -8.88e+08. In the year 2008, what is the difference between the Expenses (in $) of Labor Taxes and Expenses (in $) of Services?
Ensure brevity in your answer.  -6.38e+08. In the year 2008, what is the difference between the Expenses (in $) of Grants and Revenue and Expenses (in $) of Services?
Offer a terse response. 2.50e+08. In the year 2009, what is the difference between the Expenses (in $) of Miscellaneous expenses and Expenses (in $) of Labor Taxes?
Keep it short and to the point. 8.05e+08. In the year 2009, what is the difference between the Expenses (in $) in Miscellaneous expenses and Expenses (in $) in Grants and Revenue?
Offer a very short reply. 1.86e+08. In the year 2009, what is the difference between the Expenses (in $) in Miscellaneous expenses and Expenses (in $) in Services?
Offer a terse response. 1.41e+08. In the year 2009, what is the difference between the Expenses (in $) in Labor Taxes and Expenses (in $) in Grants and Revenue?
Provide a short and direct response. -6.20e+08. In the year 2009, what is the difference between the Expenses (in $) of Labor Taxes and Expenses (in $) of Services?
Offer a very short reply. -6.64e+08. In the year 2009, what is the difference between the Expenses (in $) of Grants and Revenue and Expenses (in $) of Services?
Offer a very short reply. -4.45e+07. In the year 2010, what is the difference between the Expenses (in $) in Miscellaneous expenses and Expenses (in $) in Labor Taxes?
Provide a short and direct response. 5.03e+08. In the year 2010, what is the difference between the Expenses (in $) in Miscellaneous expenses and Expenses (in $) in Grants and Revenue?
Your answer should be very brief. -1.89e+08. In the year 2010, what is the difference between the Expenses (in $) in Miscellaneous expenses and Expenses (in $) in Services?
Your answer should be compact. -2.30e+08. In the year 2010, what is the difference between the Expenses (in $) in Labor Taxes and Expenses (in $) in Grants and Revenue?
Keep it short and to the point. -6.92e+08. In the year 2010, what is the difference between the Expenses (in $) in Labor Taxes and Expenses (in $) in Services?
Make the answer very short. -7.33e+08. In the year 2010, what is the difference between the Expenses (in $) in Grants and Revenue and Expenses (in $) in Services?
Ensure brevity in your answer.  -4.06e+07. In the year 2011, what is the difference between the Expenses (in $) of Miscellaneous expenses and Expenses (in $) of Labor Taxes?
Ensure brevity in your answer.  7.16e+08. In the year 2011, what is the difference between the Expenses (in $) in Miscellaneous expenses and Expenses (in $) in Grants and Revenue?
Offer a terse response. -5.48e+08. In the year 2011, what is the difference between the Expenses (in $) of Miscellaneous expenses and Expenses (in $) of Services?
Keep it short and to the point. 7.42e+07. In the year 2011, what is the difference between the Expenses (in $) in Labor Taxes and Expenses (in $) in Grants and Revenue?
Your answer should be very brief. -1.26e+09. In the year 2011, what is the difference between the Expenses (in $) of Labor Taxes and Expenses (in $) of Services?
Your answer should be very brief. -6.42e+08. In the year 2011, what is the difference between the Expenses (in $) in Grants and Revenue and Expenses (in $) in Services?
Keep it short and to the point. 6.22e+08. In the year 2012, what is the difference between the Expenses (in $) in Miscellaneous expenses and Expenses (in $) in Labor Taxes?
Offer a terse response. 3.50e+08. In the year 2012, what is the difference between the Expenses (in $) in Miscellaneous expenses and Expenses (in $) in Grants and Revenue?
Your answer should be very brief. -5.37e+08. In the year 2012, what is the difference between the Expenses (in $) in Miscellaneous expenses and Expenses (in $) in Services?
Provide a succinct answer. -4.42e+08. In the year 2012, what is the difference between the Expenses (in $) in Labor Taxes and Expenses (in $) in Grants and Revenue?
Make the answer very short. -8.87e+08. In the year 2012, what is the difference between the Expenses (in $) of Labor Taxes and Expenses (in $) of Services?
Make the answer very short. -7.92e+08. In the year 2012, what is the difference between the Expenses (in $) of Grants and Revenue and Expenses (in $) of Services?
Ensure brevity in your answer.  9.54e+07. What is the ratio of the Expenses (in $) of Miscellaneous expenses in 2004 to that in 2005?
Provide a short and direct response. 4.55. What is the ratio of the Expenses (in $) of Labor Taxes in 2004 to that in 2005?
Provide a short and direct response. 0.18. What is the ratio of the Expenses (in $) of Grants and Revenue in 2004 to that in 2005?
Offer a very short reply. 1.49. What is the ratio of the Expenses (in $) in Services in 2004 to that in 2005?
Keep it short and to the point. 0.65. What is the ratio of the Expenses (in $) of Miscellaneous expenses in 2004 to that in 2006?
Give a very brief answer. 2.04. What is the ratio of the Expenses (in $) in Labor Taxes in 2004 to that in 2006?
Give a very brief answer. 0.79. What is the ratio of the Expenses (in $) in Grants and Revenue in 2004 to that in 2006?
Your answer should be compact. 0.85. What is the ratio of the Expenses (in $) in Services in 2004 to that in 2006?
Make the answer very short. 0.62. What is the ratio of the Expenses (in $) of Miscellaneous expenses in 2004 to that in 2007?
Keep it short and to the point. 1.87. What is the ratio of the Expenses (in $) of Labor Taxes in 2004 to that in 2007?
Offer a very short reply. 0.7. What is the ratio of the Expenses (in $) of Grants and Revenue in 2004 to that in 2007?
Provide a short and direct response. 0.57. What is the ratio of the Expenses (in $) of Services in 2004 to that in 2007?
Offer a very short reply. 0.65. What is the ratio of the Expenses (in $) in Miscellaneous expenses in 2004 to that in 2008?
Keep it short and to the point. 1.2. What is the ratio of the Expenses (in $) in Labor Taxes in 2004 to that in 2008?
Keep it short and to the point. 0.41. What is the ratio of the Expenses (in $) of Grants and Revenue in 2004 to that in 2008?
Keep it short and to the point. 0.43. What is the ratio of the Expenses (in $) of Services in 2004 to that in 2008?
Provide a short and direct response. 0.54. What is the ratio of the Expenses (in $) of Miscellaneous expenses in 2004 to that in 2009?
Make the answer very short. 0.89. What is the ratio of the Expenses (in $) of Labor Taxes in 2004 to that in 2009?
Your answer should be compact. 1.08. What is the ratio of the Expenses (in $) of Grants and Revenue in 2004 to that in 2009?
Provide a succinct answer. 0.63. What is the ratio of the Expenses (in $) of Services in 2004 to that in 2009?
Provide a succinct answer. 0.53. What is the ratio of the Expenses (in $) in Miscellaneous expenses in 2004 to that in 2010?
Provide a short and direct response. 1.39. What is the ratio of the Expenses (in $) of Grants and Revenue in 2004 to that in 2010?
Provide a short and direct response. 0.56. What is the ratio of the Expenses (in $) of Services in 2004 to that in 2010?
Your response must be concise. 0.48. What is the ratio of the Expenses (in $) of Miscellaneous expenses in 2004 to that in 2011?
Your response must be concise. 0.99. What is the ratio of the Expenses (in $) of Labor Taxes in 2004 to that in 2011?
Your answer should be very brief. 0.94. What is the ratio of the Expenses (in $) in Grants and Revenue in 2004 to that in 2011?
Provide a succinct answer. 0.31. What is the ratio of the Expenses (in $) of Services in 2004 to that in 2011?
Provide a succinct answer. 0.55. What is the ratio of the Expenses (in $) in Miscellaneous expenses in 2004 to that in 2012?
Provide a succinct answer. 1.96. What is the ratio of the Expenses (in $) in Labor Taxes in 2004 to that in 2012?
Offer a terse response. 0.73. What is the ratio of the Expenses (in $) of Grants and Revenue in 2004 to that in 2012?
Keep it short and to the point. 0.44. What is the ratio of the Expenses (in $) in Services in 2004 to that in 2012?
Provide a short and direct response. 0.45. What is the ratio of the Expenses (in $) of Miscellaneous expenses in 2005 to that in 2006?
Ensure brevity in your answer.  0.45. What is the ratio of the Expenses (in $) in Labor Taxes in 2005 to that in 2006?
Offer a terse response. 4.31. What is the ratio of the Expenses (in $) of Grants and Revenue in 2005 to that in 2006?
Offer a very short reply. 0.57. What is the ratio of the Expenses (in $) in Services in 2005 to that in 2006?
Provide a short and direct response. 0.96. What is the ratio of the Expenses (in $) in Miscellaneous expenses in 2005 to that in 2007?
Provide a short and direct response. 0.41. What is the ratio of the Expenses (in $) of Labor Taxes in 2005 to that in 2007?
Your response must be concise. 3.83. What is the ratio of the Expenses (in $) in Grants and Revenue in 2005 to that in 2007?
Provide a short and direct response. 0.38. What is the ratio of the Expenses (in $) of Services in 2005 to that in 2007?
Provide a succinct answer. 1. What is the ratio of the Expenses (in $) in Miscellaneous expenses in 2005 to that in 2008?
Your answer should be compact. 0.26. What is the ratio of the Expenses (in $) in Labor Taxes in 2005 to that in 2008?
Offer a terse response. 2.22. What is the ratio of the Expenses (in $) of Grants and Revenue in 2005 to that in 2008?
Your response must be concise. 0.29. What is the ratio of the Expenses (in $) in Services in 2005 to that in 2008?
Offer a very short reply. 0.82. What is the ratio of the Expenses (in $) of Miscellaneous expenses in 2005 to that in 2009?
Keep it short and to the point. 0.19. What is the ratio of the Expenses (in $) in Labor Taxes in 2005 to that in 2009?
Your answer should be compact. 5.89. What is the ratio of the Expenses (in $) of Grants and Revenue in 2005 to that in 2009?
Provide a succinct answer. 0.42. What is the ratio of the Expenses (in $) of Services in 2005 to that in 2009?
Your answer should be very brief. 0.82. What is the ratio of the Expenses (in $) in Miscellaneous expenses in 2005 to that in 2010?
Offer a very short reply. 0.31. What is the ratio of the Expenses (in $) in Labor Taxes in 2005 to that in 2010?
Offer a terse response. 4.92. What is the ratio of the Expenses (in $) in Grants and Revenue in 2005 to that in 2010?
Ensure brevity in your answer.  0.38. What is the ratio of the Expenses (in $) of Services in 2005 to that in 2010?
Keep it short and to the point. 0.74. What is the ratio of the Expenses (in $) of Miscellaneous expenses in 2005 to that in 2011?
Offer a terse response. 0.22. What is the ratio of the Expenses (in $) in Labor Taxes in 2005 to that in 2011?
Make the answer very short. 5.13. What is the ratio of the Expenses (in $) of Grants and Revenue in 2005 to that in 2011?
Offer a terse response. 0.21. What is the ratio of the Expenses (in $) in Services in 2005 to that in 2011?
Your answer should be compact. 0.84. What is the ratio of the Expenses (in $) of Miscellaneous expenses in 2005 to that in 2012?
Ensure brevity in your answer.  0.43. What is the ratio of the Expenses (in $) in Labor Taxes in 2005 to that in 2012?
Give a very brief answer. 4. What is the ratio of the Expenses (in $) in Grants and Revenue in 2005 to that in 2012?
Give a very brief answer. 0.29. What is the ratio of the Expenses (in $) of Services in 2005 to that in 2012?
Your response must be concise. 0.68. What is the ratio of the Expenses (in $) in Miscellaneous expenses in 2006 to that in 2007?
Make the answer very short. 0.92. What is the ratio of the Expenses (in $) in Labor Taxes in 2006 to that in 2007?
Provide a short and direct response. 0.89. What is the ratio of the Expenses (in $) in Grants and Revenue in 2006 to that in 2007?
Provide a succinct answer. 0.67. What is the ratio of the Expenses (in $) in Services in 2006 to that in 2007?
Offer a terse response. 1.05. What is the ratio of the Expenses (in $) in Miscellaneous expenses in 2006 to that in 2008?
Your answer should be very brief. 0.59. What is the ratio of the Expenses (in $) of Labor Taxes in 2006 to that in 2008?
Give a very brief answer. 0.51. What is the ratio of the Expenses (in $) in Grants and Revenue in 2006 to that in 2008?
Keep it short and to the point. 0.51. What is the ratio of the Expenses (in $) of Services in 2006 to that in 2008?
Provide a short and direct response. 0.86. What is the ratio of the Expenses (in $) of Miscellaneous expenses in 2006 to that in 2009?
Ensure brevity in your answer.  0.44. What is the ratio of the Expenses (in $) of Labor Taxes in 2006 to that in 2009?
Your answer should be compact. 1.37. What is the ratio of the Expenses (in $) of Grants and Revenue in 2006 to that in 2009?
Provide a short and direct response. 0.74. What is the ratio of the Expenses (in $) in Services in 2006 to that in 2009?
Keep it short and to the point. 0.85. What is the ratio of the Expenses (in $) of Miscellaneous expenses in 2006 to that in 2010?
Your response must be concise. 0.69. What is the ratio of the Expenses (in $) of Labor Taxes in 2006 to that in 2010?
Provide a short and direct response. 1.14. What is the ratio of the Expenses (in $) of Grants and Revenue in 2006 to that in 2010?
Offer a terse response. 0.66. What is the ratio of the Expenses (in $) in Services in 2006 to that in 2010?
Your answer should be very brief. 0.77. What is the ratio of the Expenses (in $) of Miscellaneous expenses in 2006 to that in 2011?
Provide a succinct answer. 0.49. What is the ratio of the Expenses (in $) in Labor Taxes in 2006 to that in 2011?
Your answer should be very brief. 1.19. What is the ratio of the Expenses (in $) in Grants and Revenue in 2006 to that in 2011?
Your response must be concise. 0.37. What is the ratio of the Expenses (in $) of Services in 2006 to that in 2011?
Give a very brief answer. 0.88. What is the ratio of the Expenses (in $) in Miscellaneous expenses in 2006 to that in 2012?
Your answer should be compact. 0.96. What is the ratio of the Expenses (in $) in Labor Taxes in 2006 to that in 2012?
Your answer should be compact. 0.93. What is the ratio of the Expenses (in $) in Grants and Revenue in 2006 to that in 2012?
Ensure brevity in your answer.  0.52. What is the ratio of the Expenses (in $) of Services in 2006 to that in 2012?
Offer a terse response. 0.71. What is the ratio of the Expenses (in $) of Miscellaneous expenses in 2007 to that in 2008?
Give a very brief answer. 0.64. What is the ratio of the Expenses (in $) of Labor Taxes in 2007 to that in 2008?
Your answer should be very brief. 0.58. What is the ratio of the Expenses (in $) of Grants and Revenue in 2007 to that in 2008?
Give a very brief answer. 0.76. What is the ratio of the Expenses (in $) of Services in 2007 to that in 2008?
Your response must be concise. 0.82. What is the ratio of the Expenses (in $) in Miscellaneous expenses in 2007 to that in 2009?
Offer a terse response. 0.47. What is the ratio of the Expenses (in $) in Labor Taxes in 2007 to that in 2009?
Provide a succinct answer. 1.54. What is the ratio of the Expenses (in $) in Grants and Revenue in 2007 to that in 2009?
Offer a terse response. 1.11. What is the ratio of the Expenses (in $) in Services in 2007 to that in 2009?
Ensure brevity in your answer.  0.82. What is the ratio of the Expenses (in $) of Miscellaneous expenses in 2007 to that in 2010?
Provide a succinct answer. 0.75. What is the ratio of the Expenses (in $) of Labor Taxes in 2007 to that in 2010?
Your answer should be compact. 1.28. What is the ratio of the Expenses (in $) of Services in 2007 to that in 2010?
Provide a short and direct response. 0.74. What is the ratio of the Expenses (in $) in Miscellaneous expenses in 2007 to that in 2011?
Your answer should be compact. 0.53. What is the ratio of the Expenses (in $) of Labor Taxes in 2007 to that in 2011?
Your answer should be compact. 1.34. What is the ratio of the Expenses (in $) in Grants and Revenue in 2007 to that in 2011?
Your answer should be very brief. 0.55. What is the ratio of the Expenses (in $) in Services in 2007 to that in 2011?
Provide a short and direct response. 0.84. What is the ratio of the Expenses (in $) of Miscellaneous expenses in 2007 to that in 2012?
Provide a short and direct response. 1.05. What is the ratio of the Expenses (in $) in Labor Taxes in 2007 to that in 2012?
Offer a terse response. 1.04. What is the ratio of the Expenses (in $) in Grants and Revenue in 2007 to that in 2012?
Provide a short and direct response. 0.78. What is the ratio of the Expenses (in $) of Services in 2007 to that in 2012?
Provide a short and direct response. 0.68. What is the ratio of the Expenses (in $) of Miscellaneous expenses in 2008 to that in 2009?
Your answer should be very brief. 0.74. What is the ratio of the Expenses (in $) of Labor Taxes in 2008 to that in 2009?
Your answer should be very brief. 2.65. What is the ratio of the Expenses (in $) of Grants and Revenue in 2008 to that in 2009?
Make the answer very short. 1.46. What is the ratio of the Expenses (in $) of Miscellaneous expenses in 2008 to that in 2010?
Give a very brief answer. 1.17. What is the ratio of the Expenses (in $) of Labor Taxes in 2008 to that in 2010?
Provide a short and direct response. 2.22. What is the ratio of the Expenses (in $) of Grants and Revenue in 2008 to that in 2010?
Ensure brevity in your answer.  1.3. What is the ratio of the Expenses (in $) of Services in 2008 to that in 2010?
Provide a succinct answer. 0.9. What is the ratio of the Expenses (in $) of Miscellaneous expenses in 2008 to that in 2011?
Offer a very short reply. 0.83. What is the ratio of the Expenses (in $) in Labor Taxes in 2008 to that in 2011?
Offer a terse response. 2.31. What is the ratio of the Expenses (in $) in Grants and Revenue in 2008 to that in 2011?
Provide a succinct answer. 0.72. What is the ratio of the Expenses (in $) of Services in 2008 to that in 2011?
Provide a short and direct response. 1.03. What is the ratio of the Expenses (in $) of Miscellaneous expenses in 2008 to that in 2012?
Ensure brevity in your answer.  1.64. What is the ratio of the Expenses (in $) in Labor Taxes in 2008 to that in 2012?
Offer a very short reply. 1.8. What is the ratio of the Expenses (in $) in Grants and Revenue in 2008 to that in 2012?
Provide a short and direct response. 1.02. What is the ratio of the Expenses (in $) in Services in 2008 to that in 2012?
Ensure brevity in your answer.  0.83. What is the ratio of the Expenses (in $) of Miscellaneous expenses in 2009 to that in 2010?
Give a very brief answer. 1.57. What is the ratio of the Expenses (in $) in Labor Taxes in 2009 to that in 2010?
Provide a succinct answer. 0.84. What is the ratio of the Expenses (in $) of Grants and Revenue in 2009 to that in 2010?
Offer a terse response. 0.89. What is the ratio of the Expenses (in $) in Services in 2009 to that in 2010?
Offer a very short reply. 0.9. What is the ratio of the Expenses (in $) of Miscellaneous expenses in 2009 to that in 2011?
Offer a terse response. 1.12. What is the ratio of the Expenses (in $) of Labor Taxes in 2009 to that in 2011?
Your response must be concise. 0.87. What is the ratio of the Expenses (in $) in Grants and Revenue in 2009 to that in 2011?
Provide a succinct answer. 0.5. What is the ratio of the Expenses (in $) of Services in 2009 to that in 2011?
Ensure brevity in your answer.  1.03. What is the ratio of the Expenses (in $) of Miscellaneous expenses in 2009 to that in 2012?
Offer a very short reply. 2.21. What is the ratio of the Expenses (in $) of Labor Taxes in 2009 to that in 2012?
Give a very brief answer. 0.68. What is the ratio of the Expenses (in $) in Grants and Revenue in 2009 to that in 2012?
Offer a very short reply. 0.7. What is the ratio of the Expenses (in $) in Services in 2009 to that in 2012?
Provide a succinct answer. 0.83. What is the ratio of the Expenses (in $) in Miscellaneous expenses in 2010 to that in 2011?
Your answer should be very brief. 0.71. What is the ratio of the Expenses (in $) in Labor Taxes in 2010 to that in 2011?
Offer a terse response. 1.04. What is the ratio of the Expenses (in $) of Grants and Revenue in 2010 to that in 2011?
Offer a very short reply. 0.55. What is the ratio of the Expenses (in $) of Services in 2010 to that in 2011?
Provide a succinct answer. 1.14. What is the ratio of the Expenses (in $) of Miscellaneous expenses in 2010 to that in 2012?
Your answer should be compact. 1.4. What is the ratio of the Expenses (in $) in Labor Taxes in 2010 to that in 2012?
Provide a succinct answer. 0.81. What is the ratio of the Expenses (in $) of Grants and Revenue in 2010 to that in 2012?
Your answer should be very brief. 0.78. What is the ratio of the Expenses (in $) of Services in 2010 to that in 2012?
Your response must be concise. 0.92. What is the ratio of the Expenses (in $) of Miscellaneous expenses in 2011 to that in 2012?
Provide a succinct answer. 1.98. What is the ratio of the Expenses (in $) of Labor Taxes in 2011 to that in 2012?
Keep it short and to the point. 0.78. What is the ratio of the Expenses (in $) of Grants and Revenue in 2011 to that in 2012?
Keep it short and to the point. 1.41. What is the ratio of the Expenses (in $) in Services in 2011 to that in 2012?
Your answer should be compact. 0.81. What is the difference between the highest and the second highest Expenses (in $) of Miscellaneous expenses?
Give a very brief answer. 8.73e+07. What is the difference between the highest and the second highest Expenses (in $) in Labor Taxes?
Provide a succinct answer. 4.59e+07. What is the difference between the highest and the second highest Expenses (in $) in Grants and Revenue?
Ensure brevity in your answer.  3.54e+08. What is the difference between the highest and the second highest Expenses (in $) in Services?
Your answer should be compact. 6.24e+07. What is the difference between the highest and the lowest Expenses (in $) in Miscellaneous expenses?
Ensure brevity in your answer.  6.60e+08. What is the difference between the highest and the lowest Expenses (in $) in Labor Taxes?
Your answer should be compact. 6.94e+07. What is the difference between the highest and the lowest Expenses (in $) of Grants and Revenue?
Offer a terse response. 1.01e+09. What is the difference between the highest and the lowest Expenses (in $) in Services?
Provide a short and direct response. 4.51e+08. 